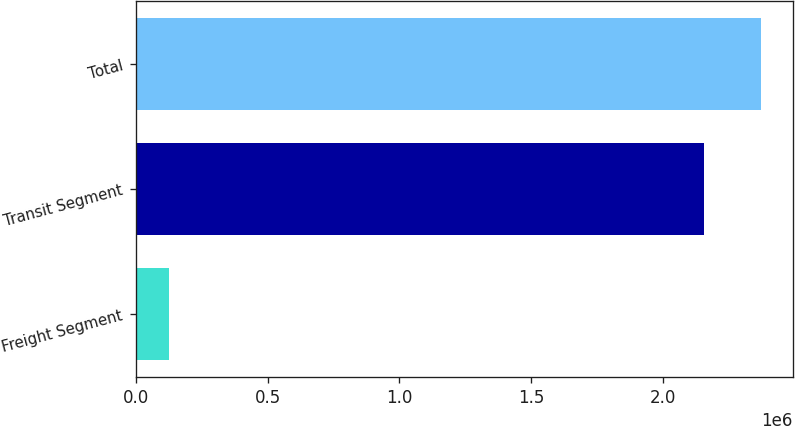Convert chart. <chart><loc_0><loc_0><loc_500><loc_500><bar_chart><fcel>Freight Segment<fcel>Transit Segment<fcel>Total<nl><fcel>125383<fcel>2.15938e+06<fcel>2.37532e+06<nl></chart> 